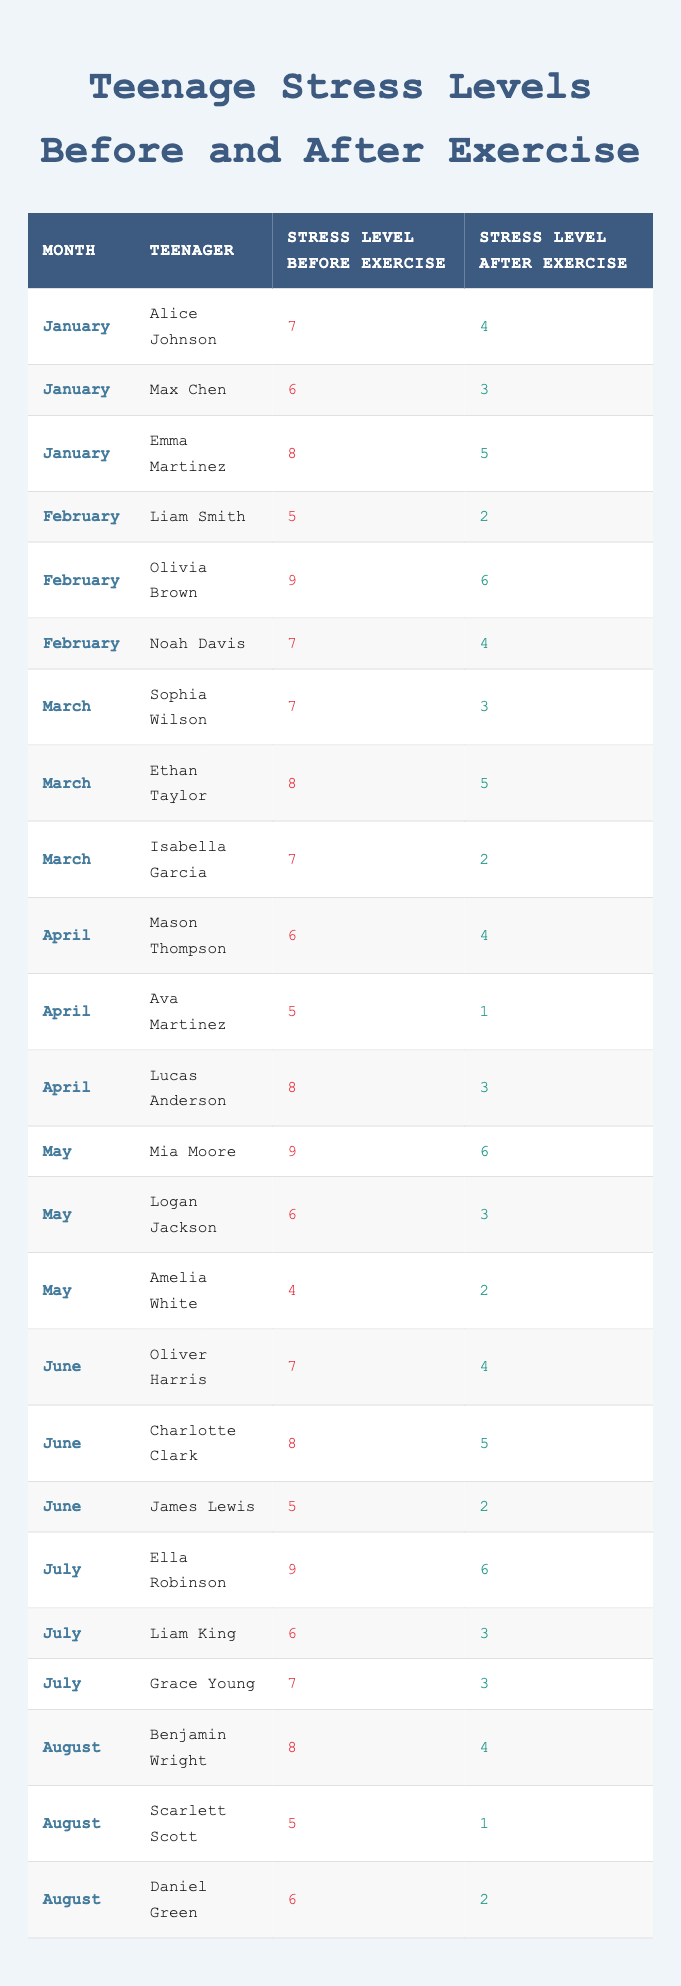What was the stress level of Emma Martinez before exercise in January? According to the table, Emma Martinez's stress level before exercise in January is listed as 8.
Answer: 8 Which teenager had the highest stress level before exercise in February? In February, Olivia Brown had the highest stress level before exercise at 9.
Answer: Olivia Brown What was the stress level difference for Liam King from before to after exercise in July? Liam King's stress level before exercise was 6, and after exercise, it was 3. The difference is calculated as 6 - 3 = 3.
Answer: 3 Who had the lowest stress level after exercise in August? In August, Scarlett Scott had the lowest stress level after exercise, which is 1.
Answer: Scarlett Scott What is the average stress level before exercise for the teenagers in March? For March, the stress levels before exercise were 7, 8, and 7. The average is calculated as (7 + 8 + 7) / 3 = 7.33.
Answer: 7.33 Is it true that Daniel Green's stress level after exercise was lower than his stress level before exercise? Daniel Green's stress level before exercise was 6, and after was 2. Since 2 is lower than 6, the statement is true.
Answer: Yes What was the total reduction in stress levels for all teenagers in January after exercise? In January, the total stress levels before exercise were 7 + 6 + 8 = 21, and after exercise, they were 4 + 3 + 5 = 12. The reduction is 21 - 12 = 9.
Answer: 9 Which month had the highest average stress level before exercise, and what was that average? Looking at the months, the stress levels before exercise for January are 7, 6, 8 (average 7.0), February is 5, 9, 7 (average 7.0), March is 7, 8, 7 (average 7.33), April is 6, 5, 8 (average 6.33), and others follow. The highest average is in March, at 7.33.
Answer: March, 7.33 How many teenagers had a stress level of 5 before exercise in June? In June, the stress levels before exercise listed are 7, 8, and 5. Only James Lewis had a stress level of 5 before exercise, making the count one.
Answer: 1 Did any teenager in July have a stress level after exercise below 3? In July, the stress levels after exercise were 6, 3, and 3. Since 3 is the lowest level and no one was below it, the answer is no.
Answer: No 